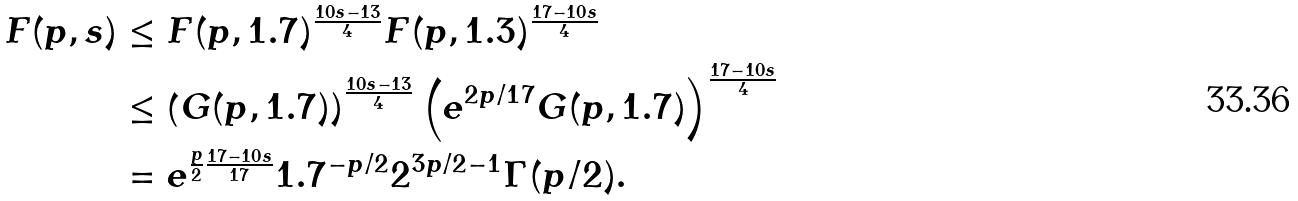Convert formula to latex. <formula><loc_0><loc_0><loc_500><loc_500>F ( p , s ) & \leq F ( p , 1 . 7 ) ^ { \frac { 1 0 s - 1 3 } { 4 } } F ( p , 1 . 3 ) ^ { \frac { 1 7 - 1 0 s } { 4 } } \\ & \leq \left ( G ( p , 1 . 7 ) \right ) ^ { \frac { 1 0 s - 1 3 } { 4 } } \left ( e ^ { 2 p / 1 7 } G ( p , 1 . 7 ) \right ) ^ { \frac { 1 7 - 1 0 s } { 4 } } \\ & = e ^ { \frac { p } { 2 } \frac { 1 7 - 1 0 s } { 1 7 } } 1 . 7 ^ { - p / 2 } 2 ^ { 3 p / 2 - 1 } \Gamma ( p / 2 ) .</formula> 